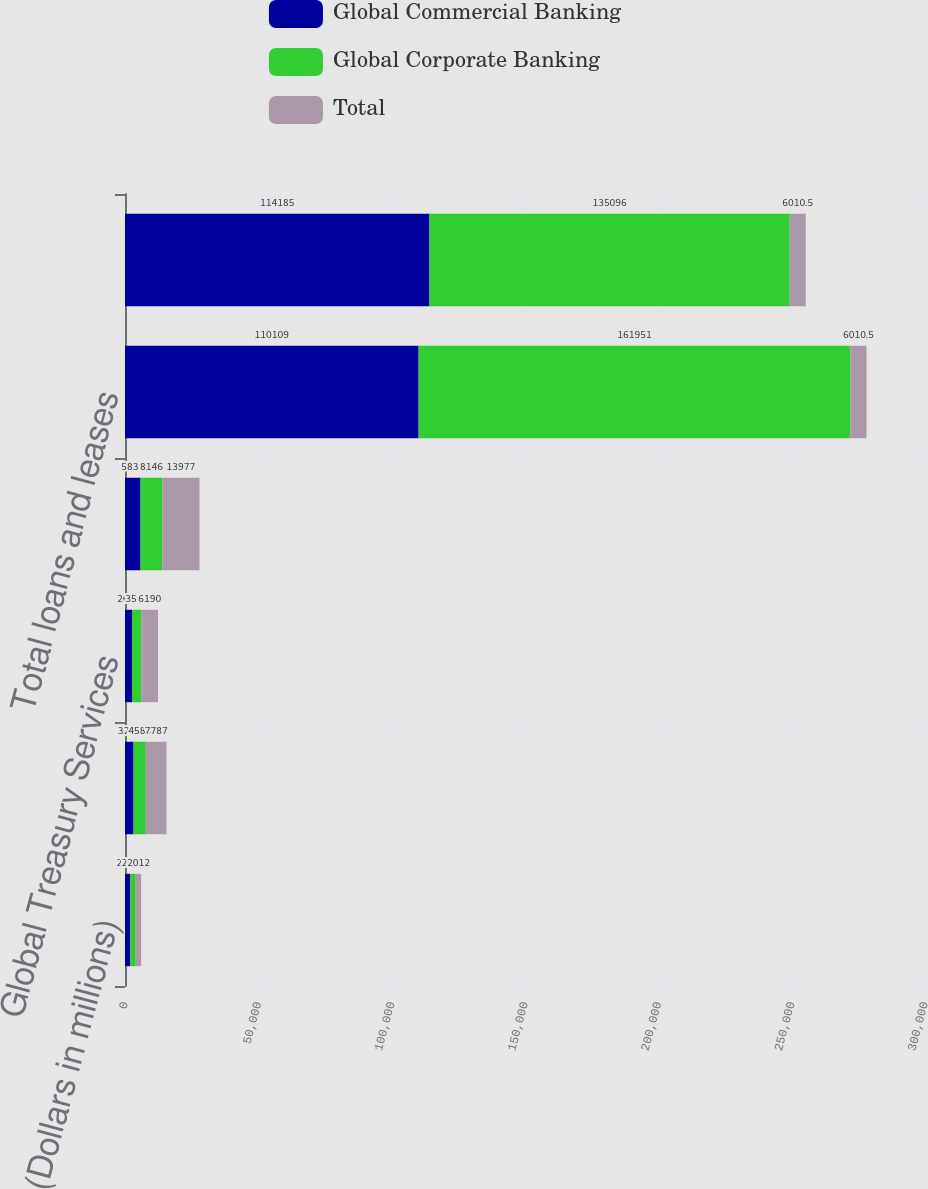<chart> <loc_0><loc_0><loc_500><loc_500><stacked_bar_chart><ecel><fcel>(Dollars in millions)<fcel>Business Lending<fcel>Global Treasury Services<fcel>Total revenue net of interest<fcel>Total loans and leases<fcel>Total deposits<nl><fcel>Global Commercial Banking<fcel>2012<fcel>3202<fcel>2629<fcel>5831<fcel>110109<fcel>114185<nl><fcel>Global Corporate Banking<fcel>2012<fcel>4585<fcel>3561<fcel>8146<fcel>161951<fcel>135096<nl><fcel>Total<fcel>2012<fcel>7787<fcel>6190<fcel>13977<fcel>6010.5<fcel>6010.5<nl></chart> 